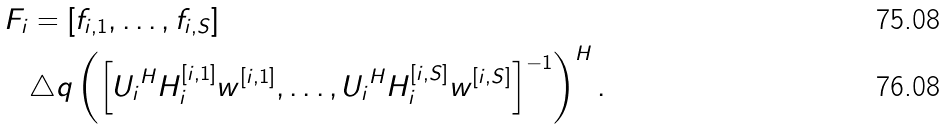<formula> <loc_0><loc_0><loc_500><loc_500>F _ { i } & = \left [ { f _ { i , 1 } } , \dots , { f _ { i , S } } \right ] \\ & \triangle q \left ( \left [ { U _ { i } } ^ { H } H _ { i } ^ { [ i , 1 ] } w ^ { [ i , 1 ] } , \dots , { U _ { i } } ^ { H } H _ { i } ^ { [ i , S ] } w ^ { [ i , S ] } \right ] ^ { - 1 } \right ) ^ { H } .</formula> 